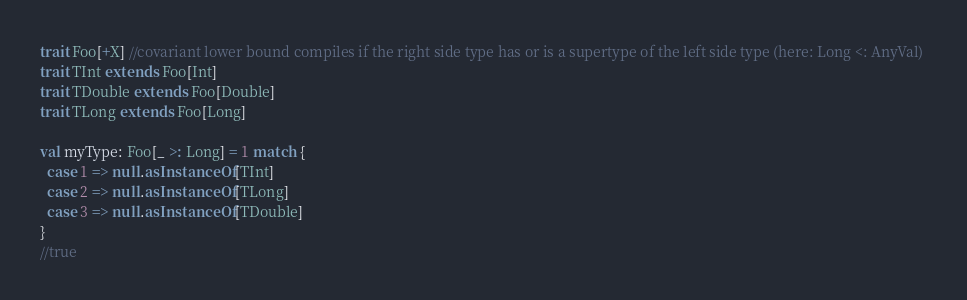Convert code to text. <code><loc_0><loc_0><loc_500><loc_500><_Scala_>trait Foo[+X] //covariant lower bound compiles if the right side type has or is a supertype of the left side type (here: Long <: AnyVal) 
trait TInt extends Foo[Int]
trait TDouble extends Foo[Double]
trait TLong extends Foo[Long]

val myType: Foo[_ >: Long] = 1 match { 
  case 1 => null.asInstanceOf[TInt]  
  case 2 => null.asInstanceOf[TLong]  
  case 3 => null.asInstanceOf[TDouble] 
}
//true</code> 